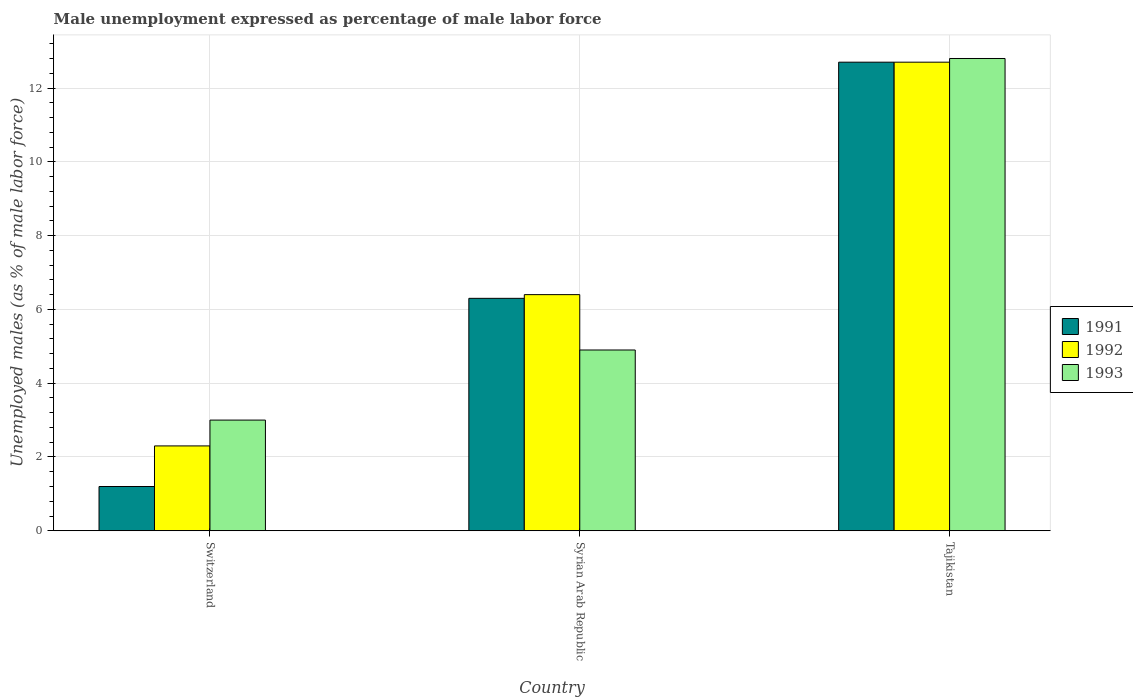How many different coloured bars are there?
Ensure brevity in your answer.  3. Are the number of bars per tick equal to the number of legend labels?
Keep it short and to the point. Yes. What is the label of the 3rd group of bars from the left?
Offer a terse response. Tajikistan. In how many cases, is the number of bars for a given country not equal to the number of legend labels?
Offer a very short reply. 0. What is the unemployment in males in in 1993 in Tajikistan?
Provide a short and direct response. 12.8. Across all countries, what is the maximum unemployment in males in in 1993?
Make the answer very short. 12.8. Across all countries, what is the minimum unemployment in males in in 1992?
Offer a very short reply. 2.3. In which country was the unemployment in males in in 1991 maximum?
Provide a short and direct response. Tajikistan. In which country was the unemployment in males in in 1991 minimum?
Ensure brevity in your answer.  Switzerland. What is the total unemployment in males in in 1991 in the graph?
Give a very brief answer. 20.2. What is the difference between the unemployment in males in in 1992 in Syrian Arab Republic and that in Tajikistan?
Your answer should be compact. -6.3. What is the difference between the unemployment in males in in 1993 in Switzerland and the unemployment in males in in 1991 in Tajikistan?
Your answer should be very brief. -9.7. What is the average unemployment in males in in 1991 per country?
Keep it short and to the point. 6.73. What is the difference between the unemployment in males in of/in 1991 and unemployment in males in of/in 1993 in Switzerland?
Offer a terse response. -1.8. In how many countries, is the unemployment in males in in 1992 greater than 11.2 %?
Keep it short and to the point. 1. What is the ratio of the unemployment in males in in 1991 in Switzerland to that in Syrian Arab Republic?
Provide a short and direct response. 0.19. Is the unemployment in males in in 1991 in Switzerland less than that in Syrian Arab Republic?
Offer a very short reply. Yes. Is the difference between the unemployment in males in in 1991 in Switzerland and Tajikistan greater than the difference between the unemployment in males in in 1993 in Switzerland and Tajikistan?
Offer a very short reply. No. What is the difference between the highest and the second highest unemployment in males in in 1992?
Provide a succinct answer. -10.4. What is the difference between the highest and the lowest unemployment in males in in 1993?
Your response must be concise. 9.8. In how many countries, is the unemployment in males in in 1993 greater than the average unemployment in males in in 1993 taken over all countries?
Offer a very short reply. 1. Is it the case that in every country, the sum of the unemployment in males in in 1991 and unemployment in males in in 1992 is greater than the unemployment in males in in 1993?
Make the answer very short. Yes. How many bars are there?
Keep it short and to the point. 9. How many countries are there in the graph?
Offer a very short reply. 3. What is the difference between two consecutive major ticks on the Y-axis?
Provide a short and direct response. 2. Does the graph contain any zero values?
Your answer should be very brief. No. Does the graph contain grids?
Ensure brevity in your answer.  Yes. How are the legend labels stacked?
Give a very brief answer. Vertical. What is the title of the graph?
Make the answer very short. Male unemployment expressed as percentage of male labor force. What is the label or title of the X-axis?
Offer a terse response. Country. What is the label or title of the Y-axis?
Keep it short and to the point. Unemployed males (as % of male labor force). What is the Unemployed males (as % of male labor force) in 1991 in Switzerland?
Your answer should be compact. 1.2. What is the Unemployed males (as % of male labor force) of 1992 in Switzerland?
Ensure brevity in your answer.  2.3. What is the Unemployed males (as % of male labor force) in 1991 in Syrian Arab Republic?
Provide a succinct answer. 6.3. What is the Unemployed males (as % of male labor force) of 1992 in Syrian Arab Republic?
Your answer should be very brief. 6.4. What is the Unemployed males (as % of male labor force) in 1993 in Syrian Arab Republic?
Offer a very short reply. 4.9. What is the Unemployed males (as % of male labor force) in 1991 in Tajikistan?
Ensure brevity in your answer.  12.7. What is the Unemployed males (as % of male labor force) in 1992 in Tajikistan?
Make the answer very short. 12.7. What is the Unemployed males (as % of male labor force) in 1993 in Tajikistan?
Offer a very short reply. 12.8. Across all countries, what is the maximum Unemployed males (as % of male labor force) in 1991?
Your response must be concise. 12.7. Across all countries, what is the maximum Unemployed males (as % of male labor force) in 1992?
Your answer should be very brief. 12.7. Across all countries, what is the maximum Unemployed males (as % of male labor force) in 1993?
Your answer should be compact. 12.8. Across all countries, what is the minimum Unemployed males (as % of male labor force) of 1991?
Your answer should be very brief. 1.2. Across all countries, what is the minimum Unemployed males (as % of male labor force) of 1992?
Your answer should be very brief. 2.3. Across all countries, what is the minimum Unemployed males (as % of male labor force) in 1993?
Offer a very short reply. 3. What is the total Unemployed males (as % of male labor force) of 1991 in the graph?
Ensure brevity in your answer.  20.2. What is the total Unemployed males (as % of male labor force) in 1992 in the graph?
Provide a short and direct response. 21.4. What is the total Unemployed males (as % of male labor force) in 1993 in the graph?
Your response must be concise. 20.7. What is the difference between the Unemployed males (as % of male labor force) in 1991 in Switzerland and that in Syrian Arab Republic?
Give a very brief answer. -5.1. What is the difference between the Unemployed males (as % of male labor force) of 1992 in Switzerland and that in Syrian Arab Republic?
Your response must be concise. -4.1. What is the difference between the Unemployed males (as % of male labor force) in 1993 in Switzerland and that in Tajikistan?
Your answer should be very brief. -9.8. What is the difference between the Unemployed males (as % of male labor force) in 1991 in Syrian Arab Republic and that in Tajikistan?
Ensure brevity in your answer.  -6.4. What is the difference between the Unemployed males (as % of male labor force) of 1993 in Syrian Arab Republic and that in Tajikistan?
Provide a succinct answer. -7.9. What is the difference between the Unemployed males (as % of male labor force) of 1991 in Switzerland and the Unemployed males (as % of male labor force) of 1992 in Syrian Arab Republic?
Keep it short and to the point. -5.2. What is the difference between the Unemployed males (as % of male labor force) of 1991 in Switzerland and the Unemployed males (as % of male labor force) of 1993 in Syrian Arab Republic?
Provide a succinct answer. -3.7. What is the difference between the Unemployed males (as % of male labor force) in 1992 in Switzerland and the Unemployed males (as % of male labor force) in 1993 in Syrian Arab Republic?
Your response must be concise. -2.6. What is the difference between the Unemployed males (as % of male labor force) in 1991 in Switzerland and the Unemployed males (as % of male labor force) in 1992 in Tajikistan?
Provide a short and direct response. -11.5. What is the difference between the Unemployed males (as % of male labor force) in 1991 in Switzerland and the Unemployed males (as % of male labor force) in 1993 in Tajikistan?
Ensure brevity in your answer.  -11.6. What is the difference between the Unemployed males (as % of male labor force) of 1991 in Syrian Arab Republic and the Unemployed males (as % of male labor force) of 1992 in Tajikistan?
Offer a terse response. -6.4. What is the difference between the Unemployed males (as % of male labor force) in 1991 in Syrian Arab Republic and the Unemployed males (as % of male labor force) in 1993 in Tajikistan?
Offer a very short reply. -6.5. What is the difference between the Unemployed males (as % of male labor force) of 1992 in Syrian Arab Republic and the Unemployed males (as % of male labor force) of 1993 in Tajikistan?
Your response must be concise. -6.4. What is the average Unemployed males (as % of male labor force) of 1991 per country?
Provide a short and direct response. 6.73. What is the average Unemployed males (as % of male labor force) of 1992 per country?
Provide a short and direct response. 7.13. What is the difference between the Unemployed males (as % of male labor force) in 1992 and Unemployed males (as % of male labor force) in 1993 in Switzerland?
Ensure brevity in your answer.  -0.7. What is the difference between the Unemployed males (as % of male labor force) in 1991 and Unemployed males (as % of male labor force) in 1992 in Syrian Arab Republic?
Make the answer very short. -0.1. What is the difference between the Unemployed males (as % of male labor force) in 1991 and Unemployed males (as % of male labor force) in 1993 in Syrian Arab Republic?
Offer a very short reply. 1.4. What is the difference between the Unemployed males (as % of male labor force) of 1991 and Unemployed males (as % of male labor force) of 1993 in Tajikistan?
Offer a very short reply. -0.1. What is the difference between the Unemployed males (as % of male labor force) in 1992 and Unemployed males (as % of male labor force) in 1993 in Tajikistan?
Provide a short and direct response. -0.1. What is the ratio of the Unemployed males (as % of male labor force) in 1991 in Switzerland to that in Syrian Arab Republic?
Provide a succinct answer. 0.19. What is the ratio of the Unemployed males (as % of male labor force) of 1992 in Switzerland to that in Syrian Arab Republic?
Ensure brevity in your answer.  0.36. What is the ratio of the Unemployed males (as % of male labor force) in 1993 in Switzerland to that in Syrian Arab Republic?
Keep it short and to the point. 0.61. What is the ratio of the Unemployed males (as % of male labor force) in 1991 in Switzerland to that in Tajikistan?
Your answer should be very brief. 0.09. What is the ratio of the Unemployed males (as % of male labor force) of 1992 in Switzerland to that in Tajikistan?
Your answer should be compact. 0.18. What is the ratio of the Unemployed males (as % of male labor force) of 1993 in Switzerland to that in Tajikistan?
Give a very brief answer. 0.23. What is the ratio of the Unemployed males (as % of male labor force) of 1991 in Syrian Arab Republic to that in Tajikistan?
Keep it short and to the point. 0.5. What is the ratio of the Unemployed males (as % of male labor force) of 1992 in Syrian Arab Republic to that in Tajikistan?
Give a very brief answer. 0.5. What is the ratio of the Unemployed males (as % of male labor force) of 1993 in Syrian Arab Republic to that in Tajikistan?
Ensure brevity in your answer.  0.38. What is the difference between the highest and the second highest Unemployed males (as % of male labor force) in 1991?
Provide a short and direct response. 6.4. What is the difference between the highest and the second highest Unemployed males (as % of male labor force) of 1992?
Offer a very short reply. 6.3. What is the difference between the highest and the second highest Unemployed males (as % of male labor force) in 1993?
Give a very brief answer. 7.9. What is the difference between the highest and the lowest Unemployed males (as % of male labor force) in 1991?
Your response must be concise. 11.5. What is the difference between the highest and the lowest Unemployed males (as % of male labor force) in 1993?
Keep it short and to the point. 9.8. 